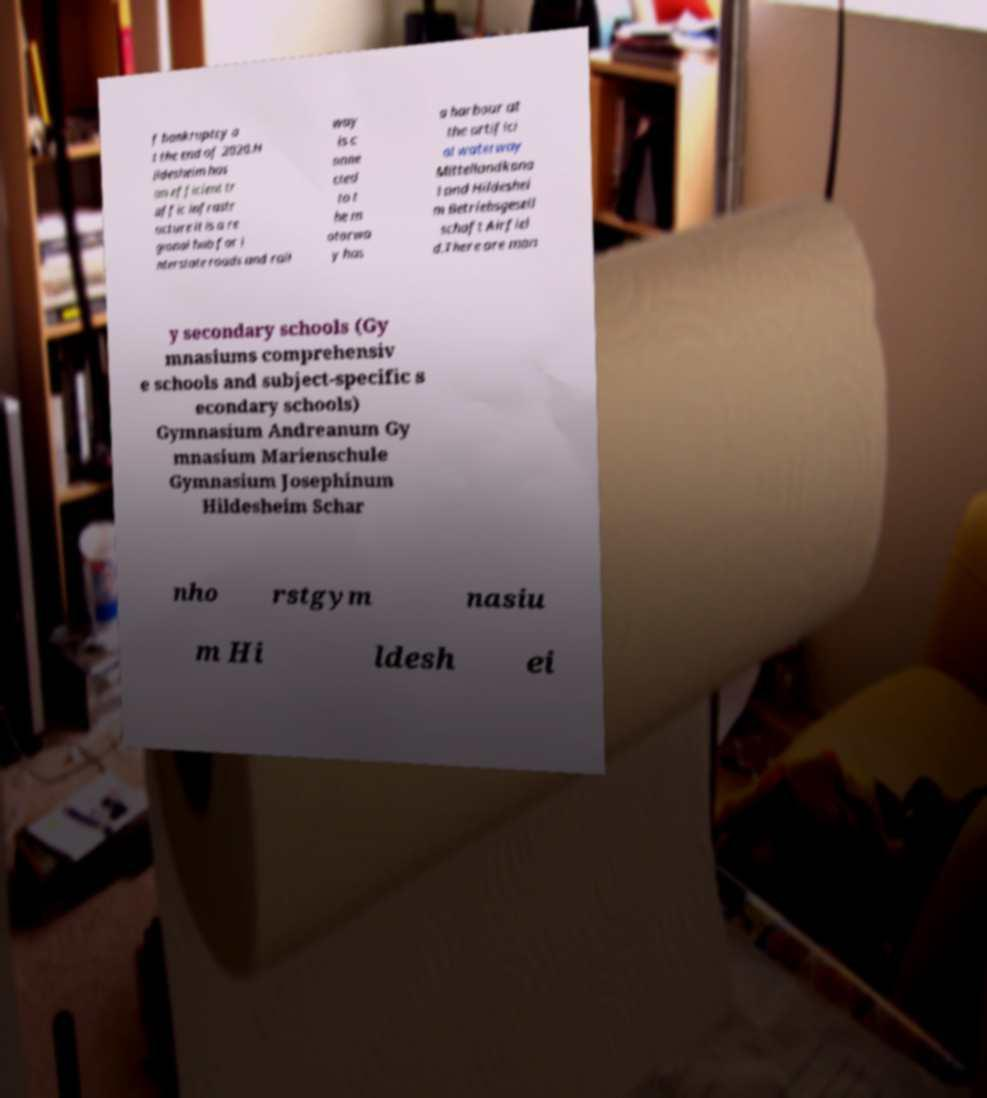I need the written content from this picture converted into text. Can you do that? f bankruptcy a t the end of 2020.H ildesheim has an efficient tr affic infrastr ucture it is a re gional hub for i nterstate roads and rail way is c onne cted to t he m otorwa y has a harbour at the artifici al waterway Mittellandkana l and Hildeshei m Betriebsgesell schaft Airfiel d.There are man y secondary schools (Gy mnasiums comprehensiv e schools and subject-specific s econdary schools) Gymnasium Andreanum Gy mnasium Marienschule Gymnasium Josephinum Hildesheim Schar nho rstgym nasiu m Hi ldesh ei 